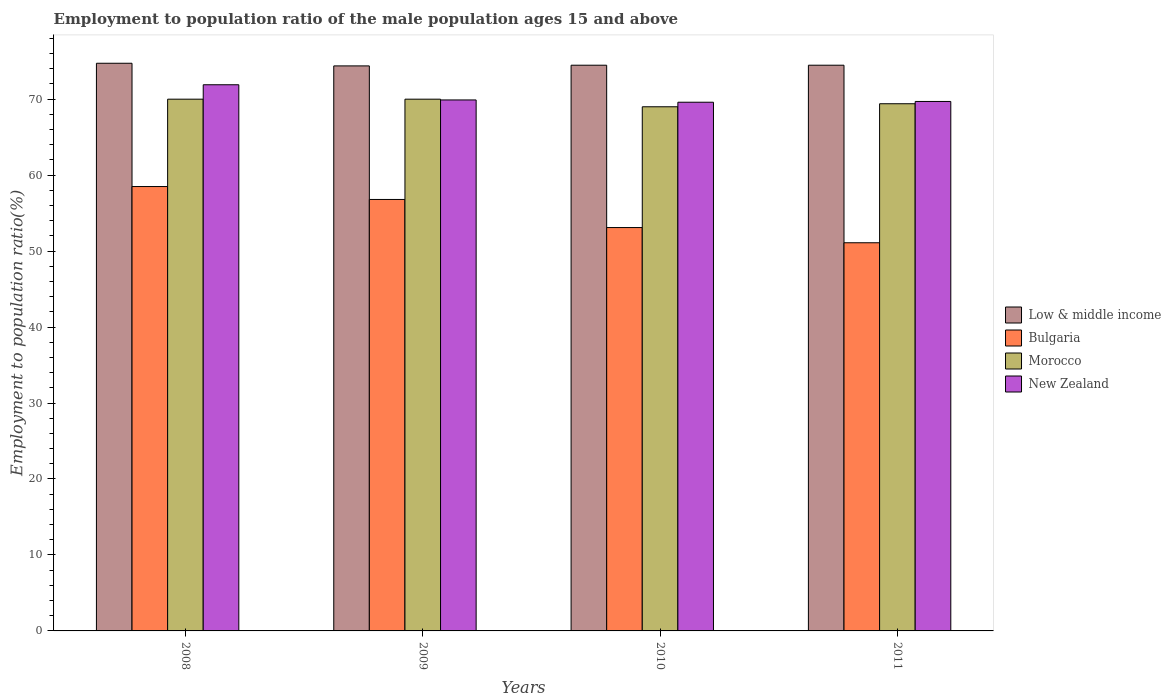How many groups of bars are there?
Give a very brief answer. 4. Are the number of bars per tick equal to the number of legend labels?
Keep it short and to the point. Yes. Are the number of bars on each tick of the X-axis equal?
Make the answer very short. Yes. How many bars are there on the 1st tick from the right?
Provide a succinct answer. 4. What is the employment to population ratio in Low & middle income in 2008?
Your answer should be compact. 74.73. Across all years, what is the minimum employment to population ratio in New Zealand?
Provide a succinct answer. 69.6. What is the total employment to population ratio in Low & middle income in the graph?
Your answer should be very brief. 298.06. What is the difference between the employment to population ratio in Low & middle income in 2009 and that in 2010?
Give a very brief answer. -0.09. What is the difference between the employment to population ratio in Bulgaria in 2010 and the employment to population ratio in New Zealand in 2009?
Your answer should be very brief. -16.8. What is the average employment to population ratio in New Zealand per year?
Make the answer very short. 70.27. In the year 2010, what is the difference between the employment to population ratio in New Zealand and employment to population ratio in Morocco?
Provide a succinct answer. 0.6. In how many years, is the employment to population ratio in Bulgaria greater than 12 %?
Provide a short and direct response. 4. What is the ratio of the employment to population ratio in Low & middle income in 2009 to that in 2010?
Your answer should be compact. 1. Is the difference between the employment to population ratio in New Zealand in 2009 and 2011 greater than the difference between the employment to population ratio in Morocco in 2009 and 2011?
Provide a short and direct response. No. What is the difference between the highest and the second highest employment to population ratio in Bulgaria?
Keep it short and to the point. 1.7. What is the difference between the highest and the lowest employment to population ratio in New Zealand?
Make the answer very short. 2.3. Is the sum of the employment to population ratio in New Zealand in 2009 and 2011 greater than the maximum employment to population ratio in Bulgaria across all years?
Offer a terse response. Yes. What does the 4th bar from the left in 2009 represents?
Provide a succinct answer. New Zealand. What does the 1st bar from the right in 2011 represents?
Make the answer very short. New Zealand. Are all the bars in the graph horizontal?
Keep it short and to the point. No. How many years are there in the graph?
Keep it short and to the point. 4. Are the values on the major ticks of Y-axis written in scientific E-notation?
Your response must be concise. No. Does the graph contain any zero values?
Offer a very short reply. No. How many legend labels are there?
Your response must be concise. 4. How are the legend labels stacked?
Keep it short and to the point. Vertical. What is the title of the graph?
Keep it short and to the point. Employment to population ratio of the male population ages 15 and above. What is the label or title of the X-axis?
Ensure brevity in your answer.  Years. What is the label or title of the Y-axis?
Keep it short and to the point. Employment to population ratio(%). What is the Employment to population ratio(%) in Low & middle income in 2008?
Your answer should be compact. 74.73. What is the Employment to population ratio(%) in Bulgaria in 2008?
Offer a very short reply. 58.5. What is the Employment to population ratio(%) of Morocco in 2008?
Give a very brief answer. 70. What is the Employment to population ratio(%) of New Zealand in 2008?
Your response must be concise. 71.9. What is the Employment to population ratio(%) in Low & middle income in 2009?
Your answer should be compact. 74.38. What is the Employment to population ratio(%) of Bulgaria in 2009?
Make the answer very short. 56.8. What is the Employment to population ratio(%) in Morocco in 2009?
Offer a terse response. 70. What is the Employment to population ratio(%) of New Zealand in 2009?
Keep it short and to the point. 69.9. What is the Employment to population ratio(%) of Low & middle income in 2010?
Your answer should be very brief. 74.47. What is the Employment to population ratio(%) in Bulgaria in 2010?
Provide a short and direct response. 53.1. What is the Employment to population ratio(%) in Morocco in 2010?
Your response must be concise. 69. What is the Employment to population ratio(%) in New Zealand in 2010?
Your response must be concise. 69.6. What is the Employment to population ratio(%) of Low & middle income in 2011?
Keep it short and to the point. 74.47. What is the Employment to population ratio(%) of Bulgaria in 2011?
Your response must be concise. 51.1. What is the Employment to population ratio(%) in Morocco in 2011?
Make the answer very short. 69.4. What is the Employment to population ratio(%) of New Zealand in 2011?
Ensure brevity in your answer.  69.7. Across all years, what is the maximum Employment to population ratio(%) of Low & middle income?
Keep it short and to the point. 74.73. Across all years, what is the maximum Employment to population ratio(%) in Bulgaria?
Offer a terse response. 58.5. Across all years, what is the maximum Employment to population ratio(%) in New Zealand?
Your answer should be very brief. 71.9. Across all years, what is the minimum Employment to population ratio(%) of Low & middle income?
Provide a succinct answer. 74.38. Across all years, what is the minimum Employment to population ratio(%) in Bulgaria?
Your response must be concise. 51.1. Across all years, what is the minimum Employment to population ratio(%) in New Zealand?
Offer a terse response. 69.6. What is the total Employment to population ratio(%) in Low & middle income in the graph?
Give a very brief answer. 298.06. What is the total Employment to population ratio(%) of Bulgaria in the graph?
Give a very brief answer. 219.5. What is the total Employment to population ratio(%) in Morocco in the graph?
Offer a terse response. 278.4. What is the total Employment to population ratio(%) of New Zealand in the graph?
Your response must be concise. 281.1. What is the difference between the Employment to population ratio(%) of Low & middle income in 2008 and that in 2009?
Provide a short and direct response. 0.35. What is the difference between the Employment to population ratio(%) in Morocco in 2008 and that in 2009?
Your answer should be compact. 0. What is the difference between the Employment to population ratio(%) in New Zealand in 2008 and that in 2009?
Keep it short and to the point. 2. What is the difference between the Employment to population ratio(%) in Low & middle income in 2008 and that in 2010?
Provide a succinct answer. 0.26. What is the difference between the Employment to population ratio(%) in New Zealand in 2008 and that in 2010?
Your response must be concise. 2.3. What is the difference between the Employment to population ratio(%) in Low & middle income in 2008 and that in 2011?
Your answer should be compact. 0.26. What is the difference between the Employment to population ratio(%) of Morocco in 2008 and that in 2011?
Keep it short and to the point. 0.6. What is the difference between the Employment to population ratio(%) in New Zealand in 2008 and that in 2011?
Your answer should be very brief. 2.2. What is the difference between the Employment to population ratio(%) of Low & middle income in 2009 and that in 2010?
Make the answer very short. -0.09. What is the difference between the Employment to population ratio(%) of Bulgaria in 2009 and that in 2010?
Make the answer very short. 3.7. What is the difference between the Employment to population ratio(%) of Low & middle income in 2009 and that in 2011?
Your answer should be very brief. -0.09. What is the difference between the Employment to population ratio(%) of Morocco in 2009 and that in 2011?
Give a very brief answer. 0.6. What is the difference between the Employment to population ratio(%) of New Zealand in 2009 and that in 2011?
Offer a very short reply. 0.2. What is the difference between the Employment to population ratio(%) of Low & middle income in 2010 and that in 2011?
Keep it short and to the point. 0. What is the difference between the Employment to population ratio(%) in Morocco in 2010 and that in 2011?
Provide a succinct answer. -0.4. What is the difference between the Employment to population ratio(%) of New Zealand in 2010 and that in 2011?
Make the answer very short. -0.1. What is the difference between the Employment to population ratio(%) in Low & middle income in 2008 and the Employment to population ratio(%) in Bulgaria in 2009?
Offer a terse response. 17.93. What is the difference between the Employment to population ratio(%) of Low & middle income in 2008 and the Employment to population ratio(%) of Morocco in 2009?
Keep it short and to the point. 4.73. What is the difference between the Employment to population ratio(%) of Low & middle income in 2008 and the Employment to population ratio(%) of New Zealand in 2009?
Make the answer very short. 4.83. What is the difference between the Employment to population ratio(%) in Morocco in 2008 and the Employment to population ratio(%) in New Zealand in 2009?
Offer a terse response. 0.1. What is the difference between the Employment to population ratio(%) in Low & middle income in 2008 and the Employment to population ratio(%) in Bulgaria in 2010?
Provide a short and direct response. 21.63. What is the difference between the Employment to population ratio(%) in Low & middle income in 2008 and the Employment to population ratio(%) in Morocco in 2010?
Make the answer very short. 5.73. What is the difference between the Employment to population ratio(%) in Low & middle income in 2008 and the Employment to population ratio(%) in New Zealand in 2010?
Your response must be concise. 5.13. What is the difference between the Employment to population ratio(%) of Low & middle income in 2008 and the Employment to population ratio(%) of Bulgaria in 2011?
Make the answer very short. 23.63. What is the difference between the Employment to population ratio(%) in Low & middle income in 2008 and the Employment to population ratio(%) in Morocco in 2011?
Keep it short and to the point. 5.33. What is the difference between the Employment to population ratio(%) in Low & middle income in 2008 and the Employment to population ratio(%) in New Zealand in 2011?
Ensure brevity in your answer.  5.03. What is the difference between the Employment to population ratio(%) in Morocco in 2008 and the Employment to population ratio(%) in New Zealand in 2011?
Give a very brief answer. 0.3. What is the difference between the Employment to population ratio(%) in Low & middle income in 2009 and the Employment to population ratio(%) in Bulgaria in 2010?
Offer a terse response. 21.28. What is the difference between the Employment to population ratio(%) in Low & middle income in 2009 and the Employment to population ratio(%) in Morocco in 2010?
Ensure brevity in your answer.  5.38. What is the difference between the Employment to population ratio(%) of Low & middle income in 2009 and the Employment to population ratio(%) of New Zealand in 2010?
Ensure brevity in your answer.  4.78. What is the difference between the Employment to population ratio(%) in Bulgaria in 2009 and the Employment to population ratio(%) in Morocco in 2010?
Your response must be concise. -12.2. What is the difference between the Employment to population ratio(%) in Bulgaria in 2009 and the Employment to population ratio(%) in New Zealand in 2010?
Provide a succinct answer. -12.8. What is the difference between the Employment to population ratio(%) in Low & middle income in 2009 and the Employment to population ratio(%) in Bulgaria in 2011?
Ensure brevity in your answer.  23.28. What is the difference between the Employment to population ratio(%) in Low & middle income in 2009 and the Employment to population ratio(%) in Morocco in 2011?
Your answer should be compact. 4.98. What is the difference between the Employment to population ratio(%) in Low & middle income in 2009 and the Employment to population ratio(%) in New Zealand in 2011?
Provide a short and direct response. 4.68. What is the difference between the Employment to population ratio(%) of Bulgaria in 2009 and the Employment to population ratio(%) of New Zealand in 2011?
Your answer should be compact. -12.9. What is the difference between the Employment to population ratio(%) of Morocco in 2009 and the Employment to population ratio(%) of New Zealand in 2011?
Keep it short and to the point. 0.3. What is the difference between the Employment to population ratio(%) in Low & middle income in 2010 and the Employment to population ratio(%) in Bulgaria in 2011?
Give a very brief answer. 23.37. What is the difference between the Employment to population ratio(%) in Low & middle income in 2010 and the Employment to population ratio(%) in Morocco in 2011?
Ensure brevity in your answer.  5.07. What is the difference between the Employment to population ratio(%) in Low & middle income in 2010 and the Employment to population ratio(%) in New Zealand in 2011?
Ensure brevity in your answer.  4.77. What is the difference between the Employment to population ratio(%) in Bulgaria in 2010 and the Employment to population ratio(%) in Morocco in 2011?
Keep it short and to the point. -16.3. What is the difference between the Employment to population ratio(%) of Bulgaria in 2010 and the Employment to population ratio(%) of New Zealand in 2011?
Offer a very short reply. -16.6. What is the difference between the Employment to population ratio(%) in Morocco in 2010 and the Employment to population ratio(%) in New Zealand in 2011?
Your answer should be very brief. -0.7. What is the average Employment to population ratio(%) of Low & middle income per year?
Provide a short and direct response. 74.51. What is the average Employment to population ratio(%) of Bulgaria per year?
Make the answer very short. 54.88. What is the average Employment to population ratio(%) in Morocco per year?
Offer a very short reply. 69.6. What is the average Employment to population ratio(%) of New Zealand per year?
Offer a very short reply. 70.28. In the year 2008, what is the difference between the Employment to population ratio(%) in Low & middle income and Employment to population ratio(%) in Bulgaria?
Provide a short and direct response. 16.23. In the year 2008, what is the difference between the Employment to population ratio(%) of Low & middle income and Employment to population ratio(%) of Morocco?
Provide a short and direct response. 4.73. In the year 2008, what is the difference between the Employment to population ratio(%) of Low & middle income and Employment to population ratio(%) of New Zealand?
Your answer should be very brief. 2.83. In the year 2008, what is the difference between the Employment to population ratio(%) in Bulgaria and Employment to population ratio(%) in Morocco?
Offer a terse response. -11.5. In the year 2008, what is the difference between the Employment to population ratio(%) of Morocco and Employment to population ratio(%) of New Zealand?
Your response must be concise. -1.9. In the year 2009, what is the difference between the Employment to population ratio(%) in Low & middle income and Employment to population ratio(%) in Bulgaria?
Provide a short and direct response. 17.58. In the year 2009, what is the difference between the Employment to population ratio(%) of Low & middle income and Employment to population ratio(%) of Morocco?
Offer a terse response. 4.38. In the year 2009, what is the difference between the Employment to population ratio(%) in Low & middle income and Employment to population ratio(%) in New Zealand?
Your response must be concise. 4.48. In the year 2009, what is the difference between the Employment to population ratio(%) in Bulgaria and Employment to population ratio(%) in Morocco?
Make the answer very short. -13.2. In the year 2009, what is the difference between the Employment to population ratio(%) in Bulgaria and Employment to population ratio(%) in New Zealand?
Provide a short and direct response. -13.1. In the year 2010, what is the difference between the Employment to population ratio(%) in Low & middle income and Employment to population ratio(%) in Bulgaria?
Your answer should be compact. 21.37. In the year 2010, what is the difference between the Employment to population ratio(%) in Low & middle income and Employment to population ratio(%) in Morocco?
Provide a short and direct response. 5.47. In the year 2010, what is the difference between the Employment to population ratio(%) in Low & middle income and Employment to population ratio(%) in New Zealand?
Your answer should be very brief. 4.87. In the year 2010, what is the difference between the Employment to population ratio(%) of Bulgaria and Employment to population ratio(%) of Morocco?
Offer a terse response. -15.9. In the year 2010, what is the difference between the Employment to population ratio(%) in Bulgaria and Employment to population ratio(%) in New Zealand?
Your response must be concise. -16.5. In the year 2011, what is the difference between the Employment to population ratio(%) in Low & middle income and Employment to population ratio(%) in Bulgaria?
Ensure brevity in your answer.  23.37. In the year 2011, what is the difference between the Employment to population ratio(%) in Low & middle income and Employment to population ratio(%) in Morocco?
Give a very brief answer. 5.07. In the year 2011, what is the difference between the Employment to population ratio(%) in Low & middle income and Employment to population ratio(%) in New Zealand?
Provide a short and direct response. 4.77. In the year 2011, what is the difference between the Employment to population ratio(%) in Bulgaria and Employment to population ratio(%) in Morocco?
Ensure brevity in your answer.  -18.3. In the year 2011, what is the difference between the Employment to population ratio(%) of Bulgaria and Employment to population ratio(%) of New Zealand?
Make the answer very short. -18.6. What is the ratio of the Employment to population ratio(%) of Low & middle income in 2008 to that in 2009?
Make the answer very short. 1. What is the ratio of the Employment to population ratio(%) in Bulgaria in 2008 to that in 2009?
Make the answer very short. 1.03. What is the ratio of the Employment to population ratio(%) in New Zealand in 2008 to that in 2009?
Offer a terse response. 1.03. What is the ratio of the Employment to population ratio(%) in Low & middle income in 2008 to that in 2010?
Your response must be concise. 1. What is the ratio of the Employment to population ratio(%) of Bulgaria in 2008 to that in 2010?
Give a very brief answer. 1.1. What is the ratio of the Employment to population ratio(%) in Morocco in 2008 to that in 2010?
Provide a short and direct response. 1.01. What is the ratio of the Employment to population ratio(%) of New Zealand in 2008 to that in 2010?
Keep it short and to the point. 1.03. What is the ratio of the Employment to population ratio(%) of Bulgaria in 2008 to that in 2011?
Provide a short and direct response. 1.14. What is the ratio of the Employment to population ratio(%) of Morocco in 2008 to that in 2011?
Your response must be concise. 1.01. What is the ratio of the Employment to population ratio(%) of New Zealand in 2008 to that in 2011?
Provide a succinct answer. 1.03. What is the ratio of the Employment to population ratio(%) in Bulgaria in 2009 to that in 2010?
Your answer should be very brief. 1.07. What is the ratio of the Employment to population ratio(%) in Morocco in 2009 to that in 2010?
Keep it short and to the point. 1.01. What is the ratio of the Employment to population ratio(%) in New Zealand in 2009 to that in 2010?
Your answer should be very brief. 1. What is the ratio of the Employment to population ratio(%) of Bulgaria in 2009 to that in 2011?
Provide a short and direct response. 1.11. What is the ratio of the Employment to population ratio(%) of Morocco in 2009 to that in 2011?
Your answer should be compact. 1.01. What is the ratio of the Employment to population ratio(%) in Low & middle income in 2010 to that in 2011?
Provide a succinct answer. 1. What is the ratio of the Employment to population ratio(%) in Bulgaria in 2010 to that in 2011?
Offer a very short reply. 1.04. What is the ratio of the Employment to population ratio(%) of New Zealand in 2010 to that in 2011?
Offer a very short reply. 1. What is the difference between the highest and the second highest Employment to population ratio(%) in Low & middle income?
Your answer should be compact. 0.26. What is the difference between the highest and the second highest Employment to population ratio(%) in Morocco?
Your answer should be very brief. 0. What is the difference between the highest and the lowest Employment to population ratio(%) in Low & middle income?
Your answer should be compact. 0.35. What is the difference between the highest and the lowest Employment to population ratio(%) in Bulgaria?
Make the answer very short. 7.4. What is the difference between the highest and the lowest Employment to population ratio(%) of New Zealand?
Make the answer very short. 2.3. 